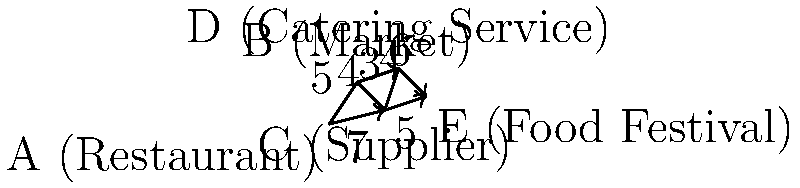As a restaurant owner focused on efficient ingredient sourcing and delivery, you need to plan the shortest route from your restaurant (A) to a food festival (E) where you'll be showcasing your dishes. The graph shows various locations and the distances between them in kilometers. What is the length of the shortest path from A to E, and which route should you take to minimize travel distance while avoiding the catering service location (D)? To find the shortest path from A to E while avoiding D, we need to consider all possible routes and their total distances:

1. A → B → C → E:
   Distance = 5 + 4 + 5 = 14 km

2. A → C → E:
   Distance = 7 + 5 = 12 km

We cannot consider routes through D as we need to avoid the catering service location.

Comparing the two possible routes:
- Route 1 (A → B → C → E) = 14 km
- Route 2 (A → C → E) = 12 km

Route 2 (A → C → E) is shorter at 12 km.

This route also aligns with the restaurant owner's persona, as it involves direct contact with the supplier (C) and avoids the catering service (D), which the owner is dubious about.
Answer: 12 km via A → C → E 